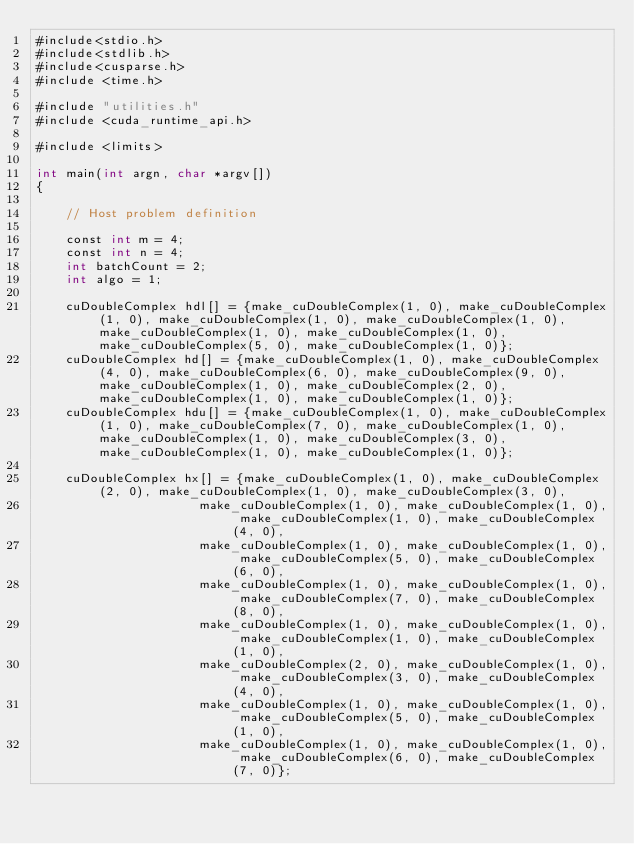<code> <loc_0><loc_0><loc_500><loc_500><_Cuda_>#include<stdio.h>
#include<stdlib.h>
#include<cusparse.h>
#include <time.h>

#include "utilities.h"
#include <cuda_runtime_api.h>

#include <limits>

int main(int argn, char *argv[])
{

    // Host problem definition

    const int m = 4;
    const int n = 4;
    int batchCount = 2;
    int algo = 1;

    cuDoubleComplex hdl[] = {make_cuDoubleComplex(1, 0), make_cuDoubleComplex(1, 0), make_cuDoubleComplex(1, 0), make_cuDoubleComplex(1, 0), make_cuDoubleComplex(1, 0), make_cuDoubleComplex(1, 0), make_cuDoubleComplex(5, 0), make_cuDoubleComplex(1, 0)};
    cuDoubleComplex hd[] = {make_cuDoubleComplex(1, 0), make_cuDoubleComplex(4, 0), make_cuDoubleComplex(6, 0), make_cuDoubleComplex(9, 0), make_cuDoubleComplex(1, 0), make_cuDoubleComplex(2, 0), make_cuDoubleComplex(1, 0), make_cuDoubleComplex(1, 0)};
    cuDoubleComplex hdu[] = {make_cuDoubleComplex(1, 0), make_cuDoubleComplex(1, 0), make_cuDoubleComplex(7, 0), make_cuDoubleComplex(1, 0), make_cuDoubleComplex(1, 0), make_cuDoubleComplex(3, 0), make_cuDoubleComplex(1, 0), make_cuDoubleComplex(1, 0)};

    cuDoubleComplex hx[] = {make_cuDoubleComplex(1, 0), make_cuDoubleComplex(2, 0), make_cuDoubleComplex(1, 0), make_cuDoubleComplex(3, 0),
                      make_cuDoubleComplex(1, 0), make_cuDoubleComplex(1, 0), make_cuDoubleComplex(1, 0), make_cuDoubleComplex(4, 0),
                      make_cuDoubleComplex(1, 0), make_cuDoubleComplex(1, 0), make_cuDoubleComplex(5, 0), make_cuDoubleComplex(6, 0),
                      make_cuDoubleComplex(1, 0), make_cuDoubleComplex(1, 0), make_cuDoubleComplex(7, 0), make_cuDoubleComplex(8, 0),
                      make_cuDoubleComplex(1, 0), make_cuDoubleComplex(1, 0), make_cuDoubleComplex(1, 0), make_cuDoubleComplex(1, 0),
                      make_cuDoubleComplex(2, 0), make_cuDoubleComplex(1, 0), make_cuDoubleComplex(3, 0), make_cuDoubleComplex(4, 0),
                      make_cuDoubleComplex(1, 0), make_cuDoubleComplex(1, 0), make_cuDoubleComplex(5, 0), make_cuDoubleComplex(1, 0),
                      make_cuDoubleComplex(1, 0), make_cuDoubleComplex(1, 0), make_cuDoubleComplex(6, 0), make_cuDoubleComplex(7, 0)};
</code> 